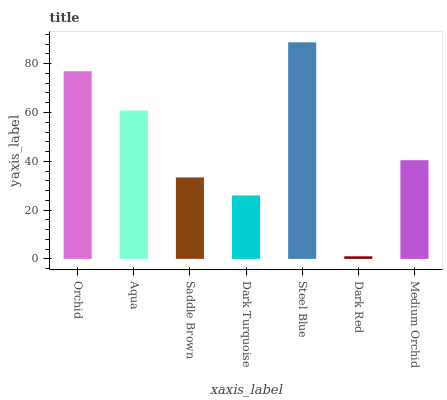Is Dark Red the minimum?
Answer yes or no. Yes. Is Steel Blue the maximum?
Answer yes or no. Yes. Is Aqua the minimum?
Answer yes or no. No. Is Aqua the maximum?
Answer yes or no. No. Is Orchid greater than Aqua?
Answer yes or no. Yes. Is Aqua less than Orchid?
Answer yes or no. Yes. Is Aqua greater than Orchid?
Answer yes or no. No. Is Orchid less than Aqua?
Answer yes or no. No. Is Medium Orchid the high median?
Answer yes or no. Yes. Is Medium Orchid the low median?
Answer yes or no. Yes. Is Orchid the high median?
Answer yes or no. No. Is Orchid the low median?
Answer yes or no. No. 